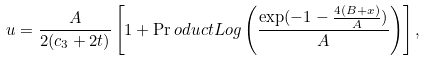Convert formula to latex. <formula><loc_0><loc_0><loc_500><loc_500>u = \frac { A } { 2 ( c _ { 3 } + 2 t ) } \left [ 1 + \Pr o d u c t L o g \left ( \frac { \exp ( - 1 - \frac { 4 ( B + x ) } { A } ) } { A } \right ) \right ] ,</formula> 